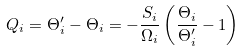<formula> <loc_0><loc_0><loc_500><loc_500>Q _ { i } = \Theta _ { i } ^ { \prime } - \Theta _ { i } = - \frac { S _ { i } } { \Omega _ { i } } \left ( \frac { \Theta _ { i } } { \Theta _ { i } ^ { \prime } } - 1 \right ) \</formula> 